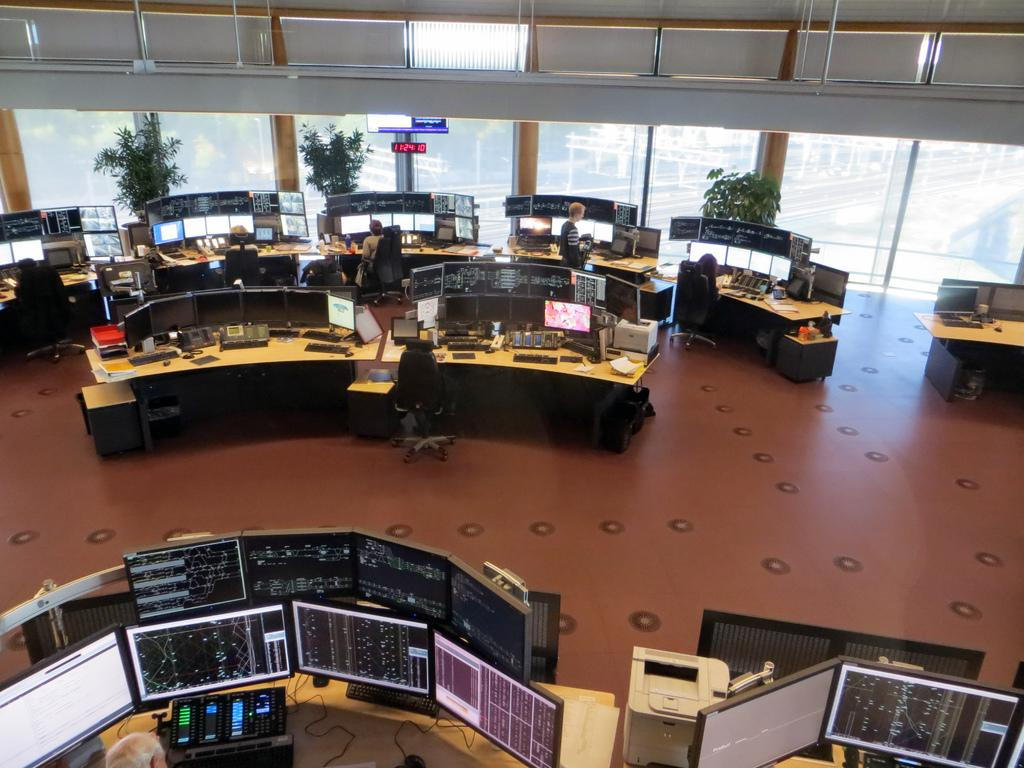What can be seen in the image related to technology or organization? There are systems in the image. What is happening in the background of the image? There are people sitting in the background of the image. What type of vegetation is present in the image? There are plants with a green color in the image. What type of architectural feature can be seen in the image? There are glass walls visible in the image. What type of pleasure can be seen being enjoyed by the lawyer in the image? There is no lawyer or pleasure present in the image. 